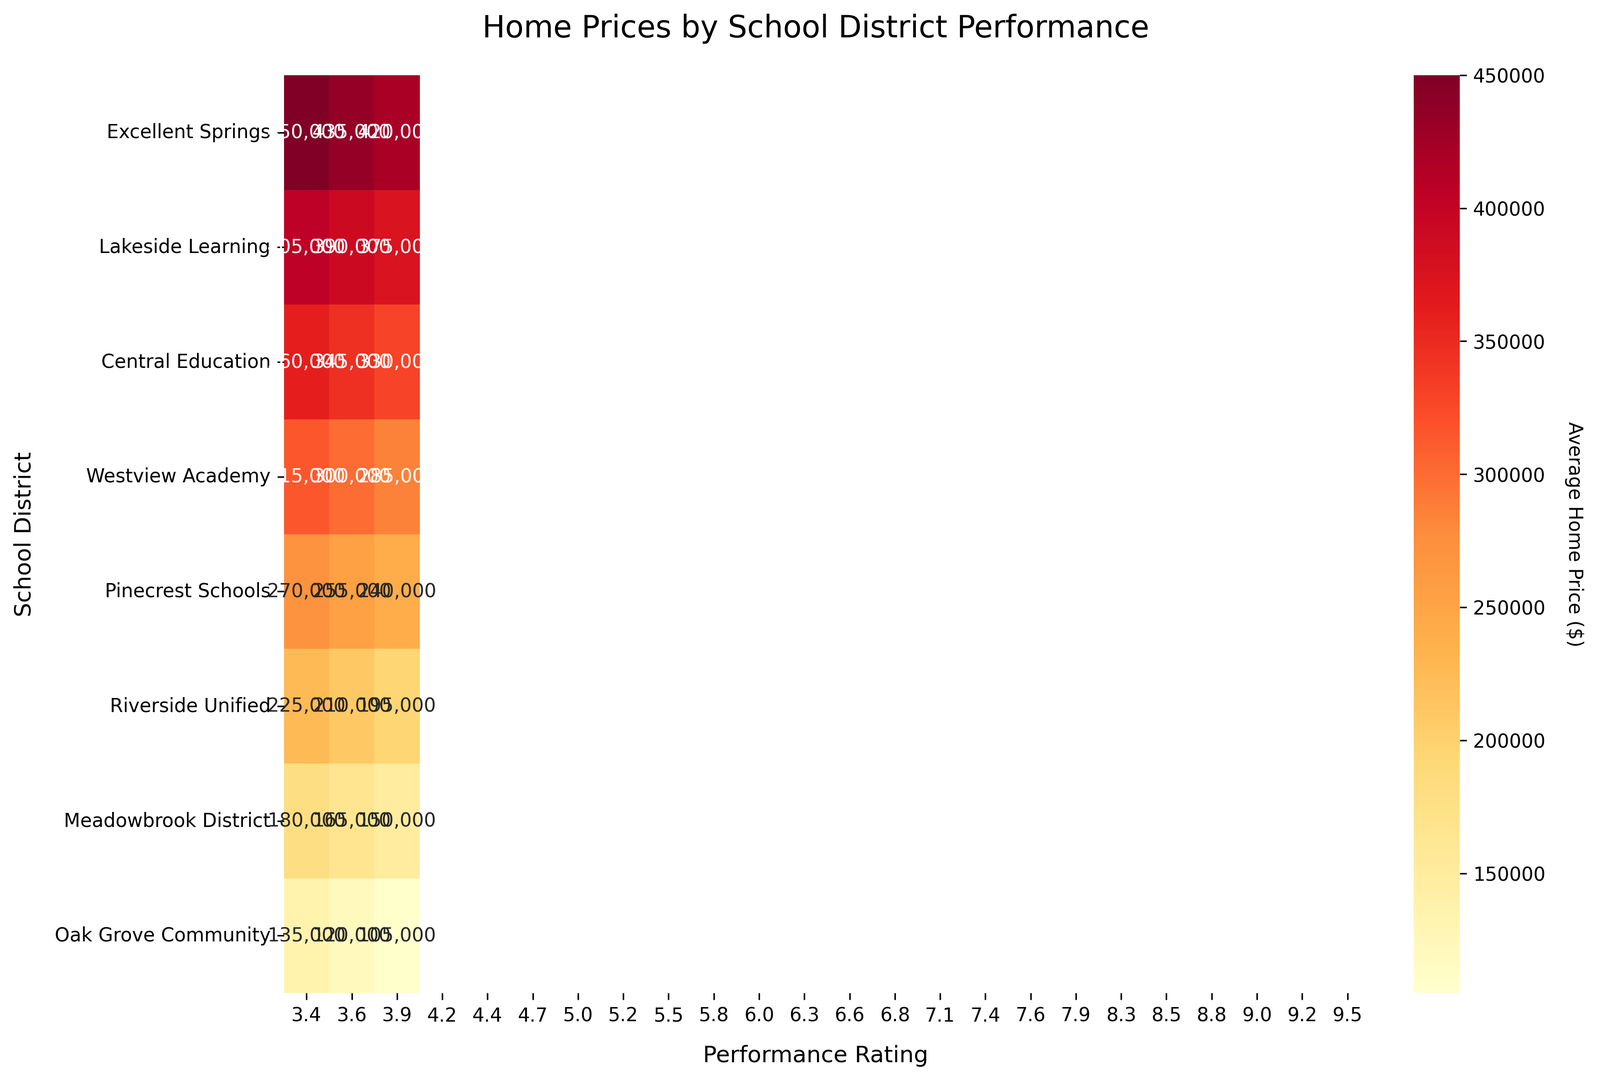What is the average home price in the "Excellent Springs" school district for the highest performance rating? Looking at the heatmap, the highest performance rating in "Excellent Springs" is 9.5. The home price for this rating is $450,000.
Answer: $450,000 Which school district has the lowest average home price for the highest performance rating, and what is that price? By examining the highest ratings for each district along the x-axis, "Oak Grove Community" has the highest rating of 3.9 and the corresponding home price is $135,000.
Answer: Oak Grove Community, $135,000 Is there a visible trend in home prices with respect to performance ratings in "Lakeside Learning"? In the "Lakeside Learning" district, as the performance rating decreases from 8.8 to 8.3, home prices decrease from $405,000 to $375,000, indicating a correlation between higher performance ratings and higher home prices.
Answer: Prices decrease with rating Compare the average home prices of "Westview Academy" and "Pinecrest Schools" when the performance rating is approximately 7.0. For the performance rating closest to 7.0, "Westview Academy" has a home price of $315,000 (rating 7.1) while "Pinecrest Schools" has $240,000 (rating 5.8). The price at "Westview Academy" is higher.
Answer: Westview Academy is higher What is the difference in home prices between the highest and lowest performance ratings within "Riverside Unified"? For "Riverside Unified", the highest performance rating is 5.5 with a home price of $225,000, and the lowest is 5.0 with a price of $195,000. The difference is $225,000 - $195,000 = $30,000.
Answer: $30,000 How does the color intensity change in relation to performance ratings in "Central Education"? Observing "Central Education", as performance ratings decrease from 7.9 to 7.4, the cell colors become darker shades of red, indicating decreasing home prices.
Answer: Darker with lower ratings Which district has the most consistent home prices across different performance ratings? On the heatmap, "Excellent Springs" shows relatively consistent home prices ranging from $420,000 to $450,000 across its performance ratings.
Answer: Excellent Springs What is the average home price for "Meadowbrook District" across all performance ratings? "Meadowbrook District" has home prices of $180,000, $165,000, and $150,000 for ratings 4.7, 4.4, and 4.2 respectively. Average = ($180,000 + $165,000 + $150,000) / 3 = $495,000 / 3.
Answer: $165,000 